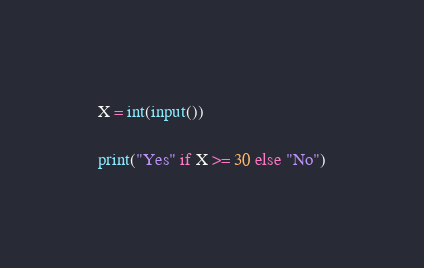Convert code to text. <code><loc_0><loc_0><loc_500><loc_500><_Python_>X = int(input())

print("Yes" if X >= 30 else "No")
</code> 